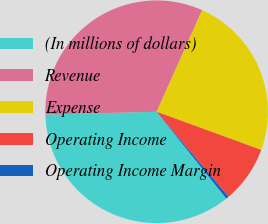Convert chart to OTSL. <chart><loc_0><loc_0><loc_500><loc_500><pie_chart><fcel>(In millions of dollars)<fcel>Revenue<fcel>Expense<fcel>Operating Income<fcel>Operating Income Margin<nl><fcel>35.36%<fcel>32.11%<fcel>23.85%<fcel>8.26%<fcel>0.42%<nl></chart> 